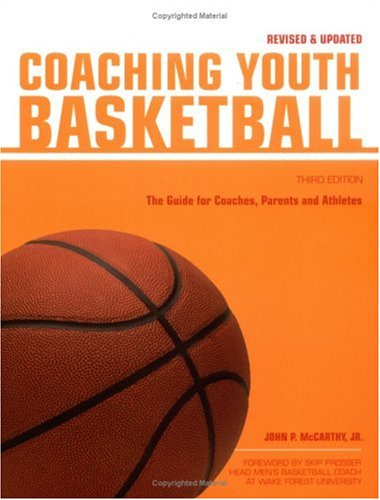Who is the target audience for this book? The primary audience for this book includes both new and experienced coaches, as well as parents who are involved in coaching basketball at the youth level. 